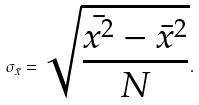<formula> <loc_0><loc_0><loc_500><loc_500>\sigma _ { \bar { x } } = \sqrt { \frac { \bar { x ^ { 2 } } - \bar { x } ^ { 2 } } { N } } .</formula> 